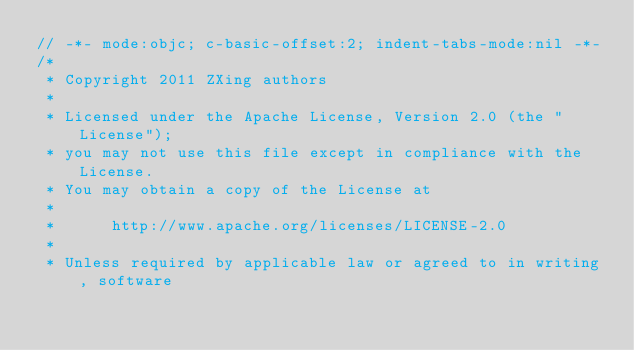Convert code to text. <code><loc_0><loc_0><loc_500><loc_500><_ObjectiveC_>// -*- mode:objc; c-basic-offset:2; indent-tabs-mode:nil -*-
/*
 * Copyright 2011 ZXing authors
 *
 * Licensed under the Apache License, Version 2.0 (the "License");
 * you may not use this file except in compliance with the License.
 * You may obtain a copy of the License at
 *
 *      http://www.apache.org/licenses/LICENSE-2.0
 *
 * Unless required by applicable law or agreed to in writing, software</code> 